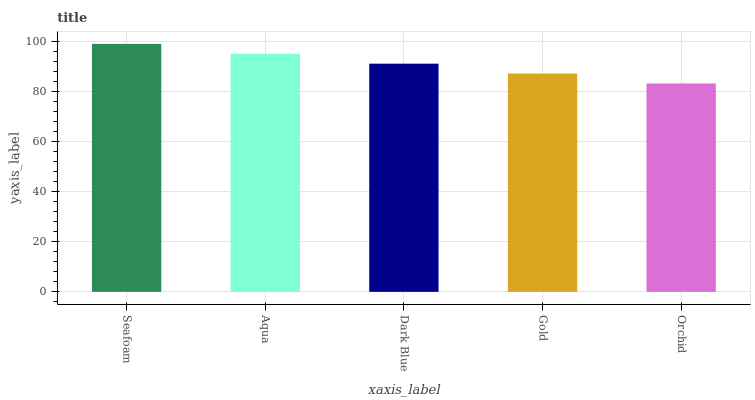Is Orchid the minimum?
Answer yes or no. Yes. Is Seafoam the maximum?
Answer yes or no. Yes. Is Aqua the minimum?
Answer yes or no. No. Is Aqua the maximum?
Answer yes or no. No. Is Seafoam greater than Aqua?
Answer yes or no. Yes. Is Aqua less than Seafoam?
Answer yes or no. Yes. Is Aqua greater than Seafoam?
Answer yes or no. No. Is Seafoam less than Aqua?
Answer yes or no. No. Is Dark Blue the high median?
Answer yes or no. Yes. Is Dark Blue the low median?
Answer yes or no. Yes. Is Orchid the high median?
Answer yes or no. No. Is Seafoam the low median?
Answer yes or no. No. 